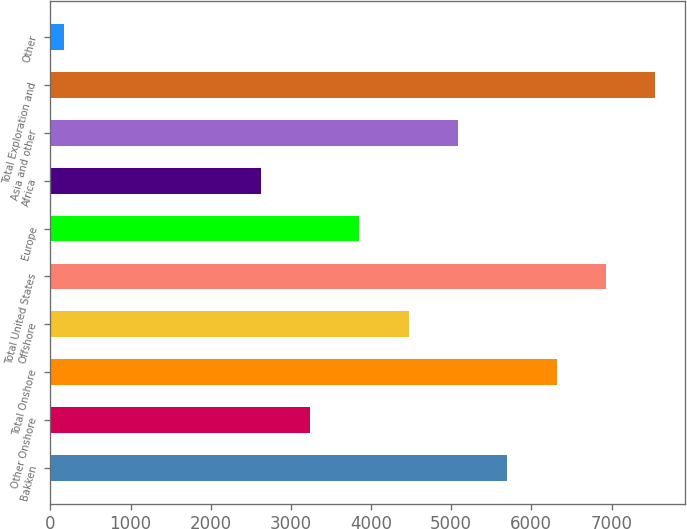Convert chart to OTSL. <chart><loc_0><loc_0><loc_500><loc_500><bar_chart><fcel>Bakken<fcel>Other Onshore<fcel>Total Onshore<fcel>Offshore<fcel>Total United States<fcel>Europe<fcel>Africa<fcel>Asia and other<fcel>Total Exploration and<fcel>Other<nl><fcel>5699.9<fcel>3239.5<fcel>6315<fcel>4469.7<fcel>6930.1<fcel>3854.6<fcel>2624.4<fcel>5084.8<fcel>7545.2<fcel>164<nl></chart> 